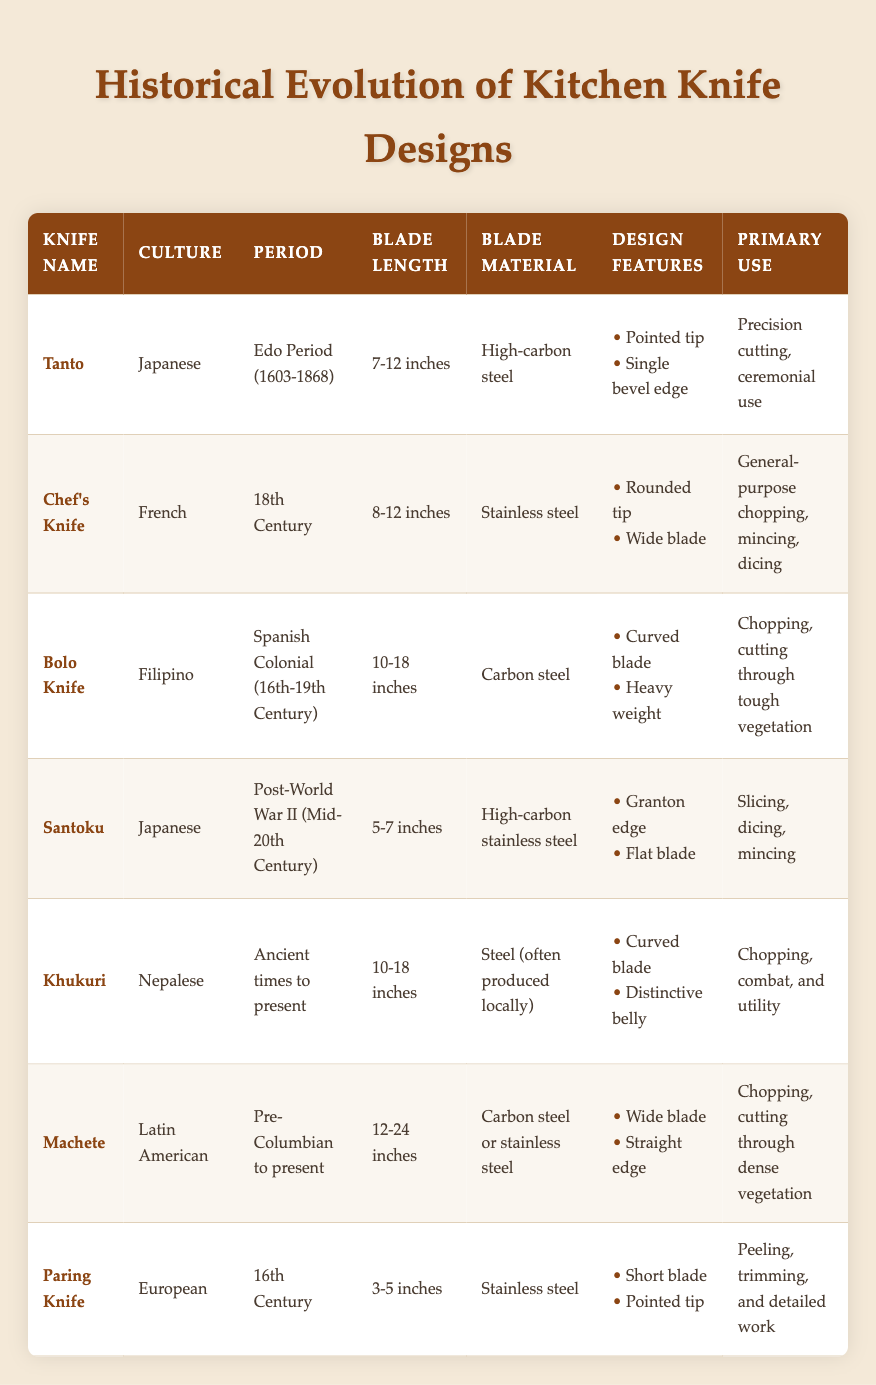What is the primary use of the Tanto knife? The primary use of the Tanto knife, according to the table, is precision cutting and ceremonial use. This information is found in the "Primary Use" column for the Tanto knife entry.
Answer: Precision cutting, ceremonial use Which knife has a blade length of 3-5 inches? The Paring Knife is the only knife listed with a blade length of 3-5 inches, as specified in the "Blade Length" column of the table.
Answer: Paring Knife How many different cultures are represented in the table? There are six different cultures listed in the table: Japanese, French, Filipino, Nepalese, Latin American, and European. Each culture corresponds to the respective knife names.
Answer: Six Which knife has the longest blade length range? The Machete has the longest blade length range, from 12-24 inches, as shown in the "Blade Length" column, which is longer than any other knife listed in the table.
Answer: Machete Is the Santoku knife made from stainless steel? No, the Santoku knife is made from high-carbon stainless steel, as stated in the "Blade Material" column of the table, which does not qualify as regular stainless steel.
Answer: No What are the main design features of the Bolo Knife? The main design features of the Bolo Knife are a curved blade and heavy weight. This information is provided in the "Design Features" column for the Bolo Knife entry.
Answer: Curved blade, heavy weight How do the typical blade lengths of Japanese knives compare to those of European knives? The Tanto knife has a blade length of 7-12 inches while the Santoku has a blade length of 5-7 inches, making their average blade lengths range from 5-12 inches. The European Paring Knife has a shorter blade of 3-5 inches. This indicates that Japanese knives generally have a longer average blade length compared to the European Paring Knife.
Answer: Japanese knives are longer on average Which knives are designed for chopping? The Bolo knife, Khukuri, and Machete are identified as designed for chopping in the "Primary Use" column of the table. This collectively indicates a focus on heavy cutting tasks across different cultures.
Answer: Bolo knife, Khukuri, Machete What is the average blade length of the French Chef's Knife and the Nepalese Khukuri? The French Chef's Knife has a blade length of 8-12 inches, which translates to an average of 10 inches. The Khukuri has a blade length range of 10-18 inches, or an average of 14 inches. This means the average blade length between these two knives is (10 + 14)/2 = 12 inches. The final average illustrates a middle ground between these two knife designs.
Answer: 12 inches 